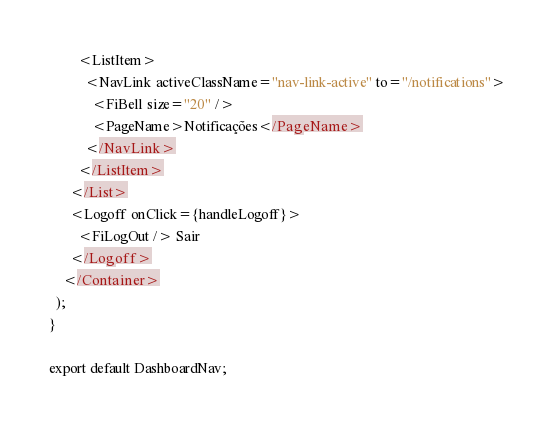Convert code to text. <code><loc_0><loc_0><loc_500><loc_500><_JavaScript_>        <ListItem>
          <NavLink activeClassName="nav-link-active" to="/notifications">
            <FiBell size="20" />
            <PageName>Notificações</PageName>
          </NavLink>
        </ListItem>
      </List>
      <Logoff onClick={handleLogoff}>
        <FiLogOut /> Sair
      </Logoff>
    </Container>
  );
}

export default DashboardNav;
</code> 